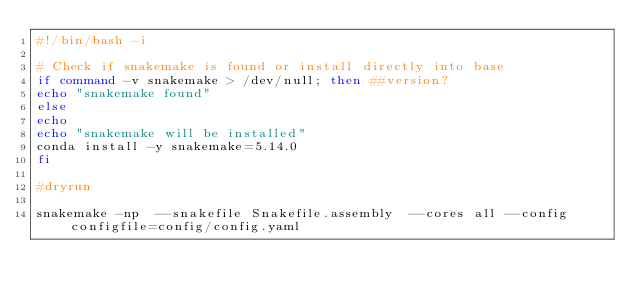Convert code to text. <code><loc_0><loc_0><loc_500><loc_500><_Bash_>#!/bin/bash -i

# Check if snakemake is found or install directly into base
if command -v snakemake > /dev/null; then ##version?
echo "snakemake found"
else
echo
echo "snakemake will be installed"
conda install -y snakemake=5.14.0
fi

#dryrun

snakemake -np  --snakefile Snakefile.assembly  --cores all --config configfile=config/config.yaml
</code> 